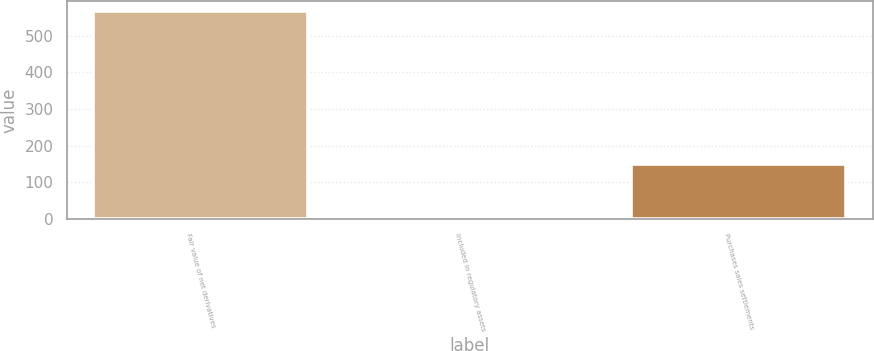Convert chart. <chart><loc_0><loc_0><loc_500><loc_500><bar_chart><fcel>Fair value of net derivatives<fcel>Included in regulatory assets<fcel>Purchases sales settlements<nl><fcel>566<fcel>5<fcel>151<nl></chart> 